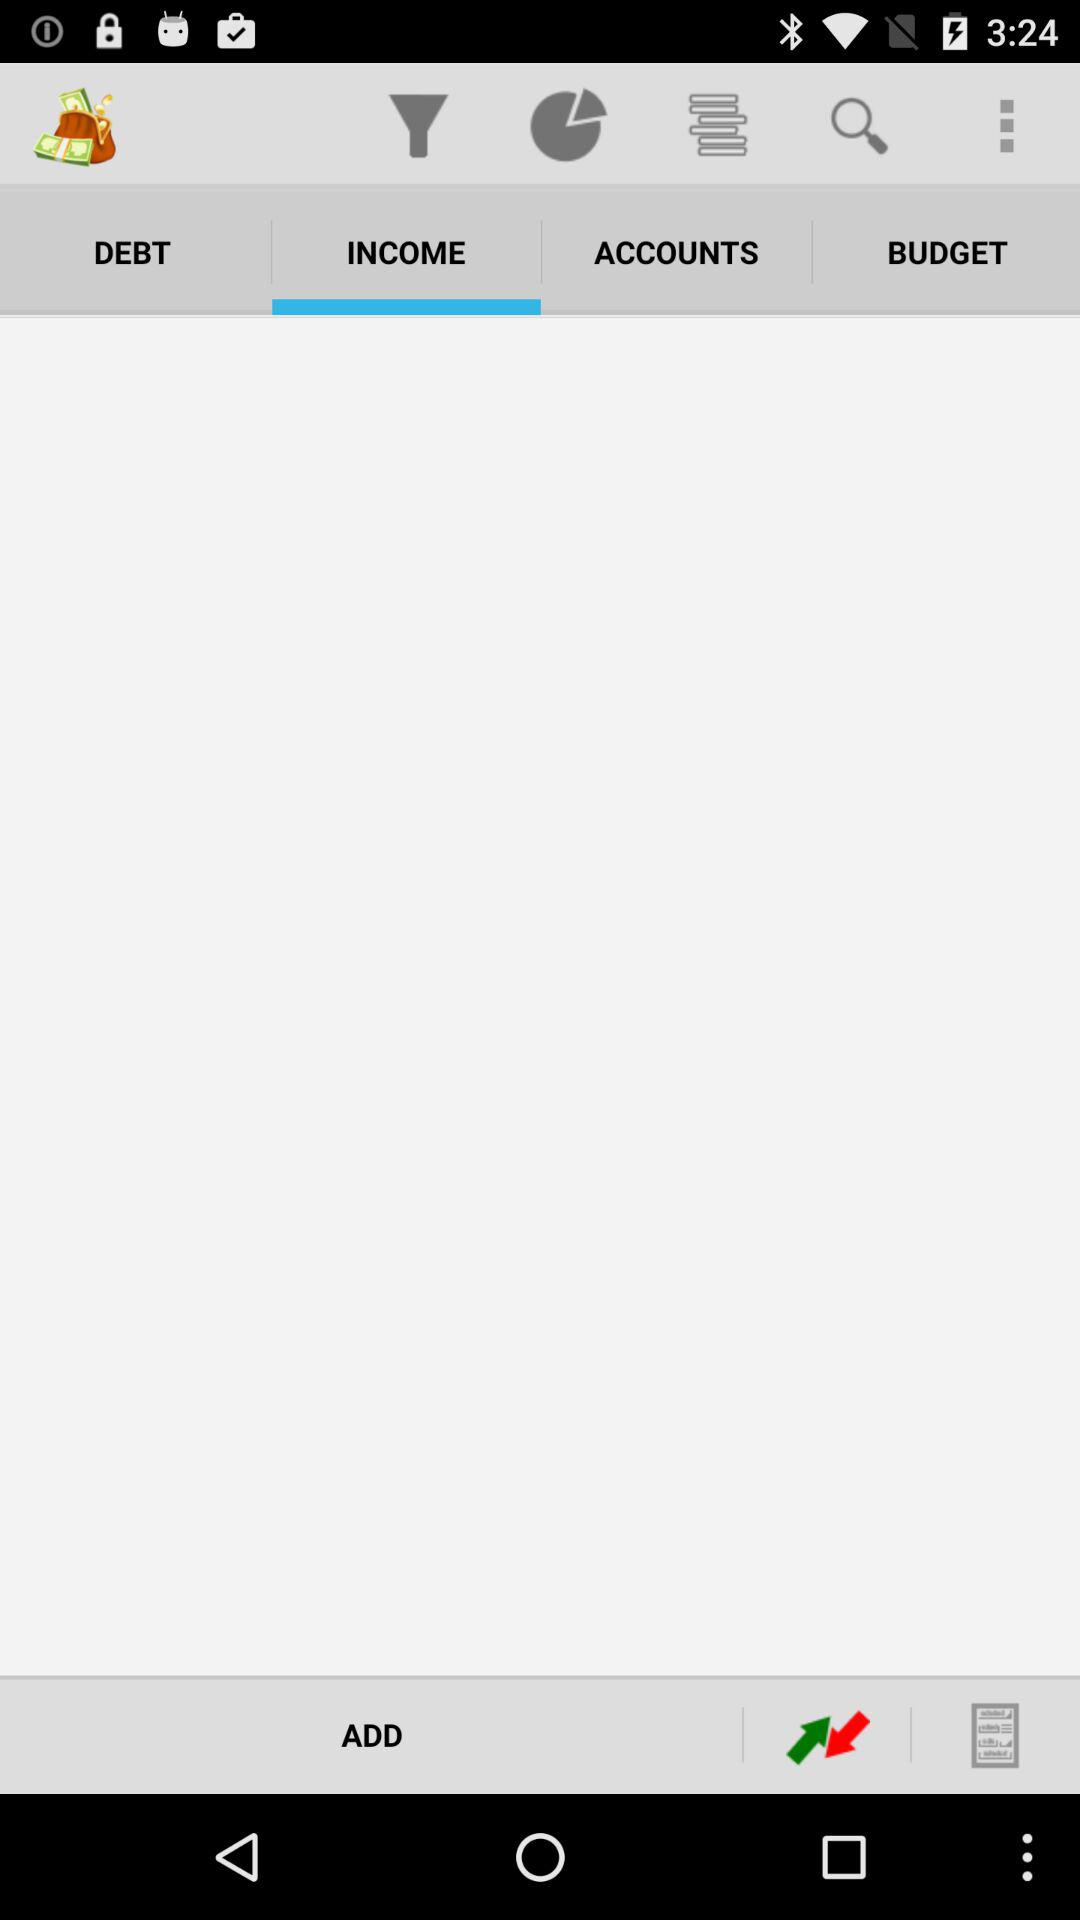Which tab is selected? The selected tab is "INCOME". 